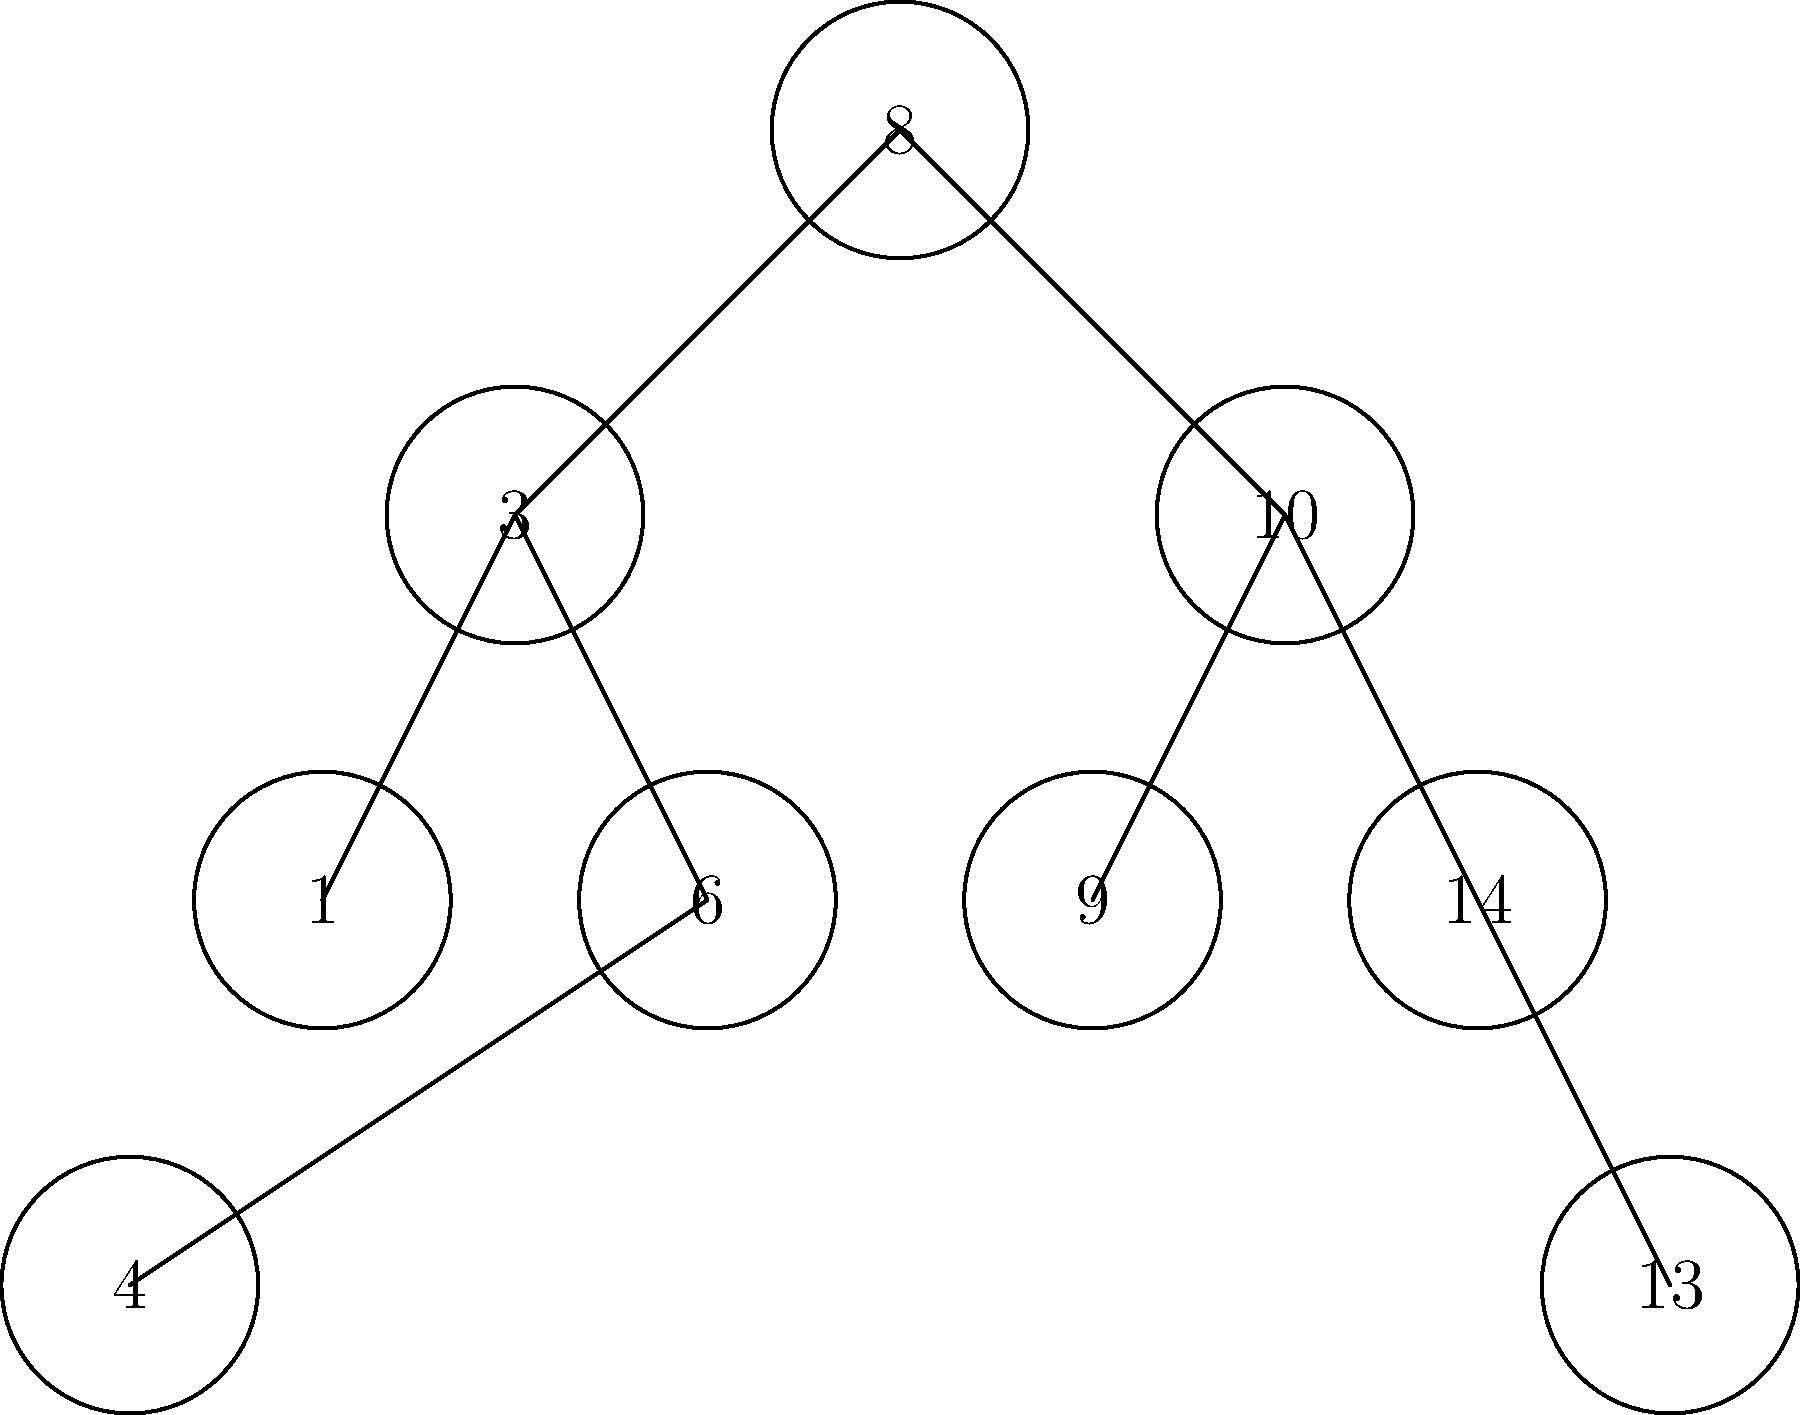Given the binary search tree shown in the diagram, which was constructed by inserting the values in the order they appear from left to right and top to bottom, what is the height of the tree? Additionally, what is the time complexity of searching for the value 13 in this tree? To solve this problem, let's break it down into steps:

1. Determine the height of the tree:
   - The root node (8) is at level 0.
   - The next level (3 and 10) is level 1.
   - The next level (1, 6, 9, and 14) is level 2.
   - The deepest level (4 and 13) is level 3.
   - The height of a tree is the number of edges from the root to the deepest leaf.
   - Therefore, the height of this tree is 3.

2. Analyze the time complexity of searching for 13:
   - Start at the root (8). Since 13 > 8, move to the right child.
   - At node 10, since 13 > 10, move to the right child.
   - At node 14, since 13 < 14, move to the left child.
   - Arrive at node 13, which is the target value.
   - We made 3 comparisons to reach the value 13.
   - In a binary search tree, the time complexity of searching is O(h), where h is the height of the tree.
   - Since the height of this tree is 3, and we made 3 comparisons, the time complexity is O(h) = O(3) = O(log n), where n is the number of nodes in the tree.

Therefore, the height of the tree is 3, and the time complexity of searching for 13 is O(log n).
Answer: Height: 3, Time complexity: O(log n) 